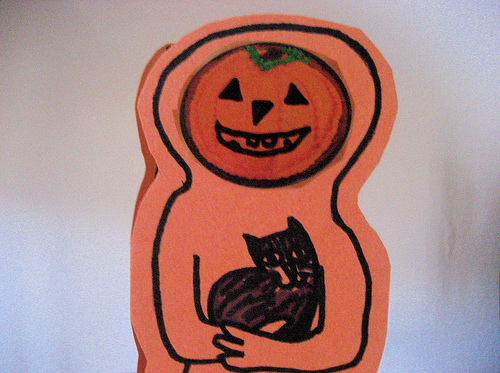<image>
Is the pumpkin next to the cat? No. The pumpkin is not positioned next to the cat. They are located in different areas of the scene. 